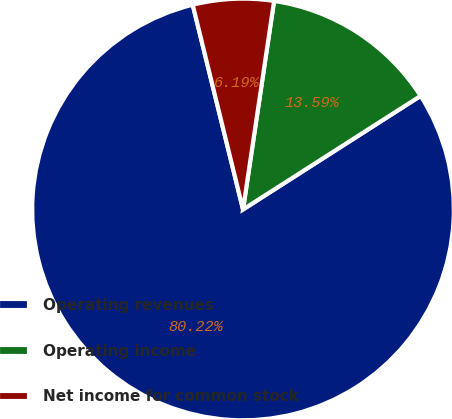Convert chart to OTSL. <chart><loc_0><loc_0><loc_500><loc_500><pie_chart><fcel>Operating revenues<fcel>Operating income<fcel>Net income for common stock<nl><fcel>80.22%<fcel>13.59%<fcel>6.19%<nl></chart> 